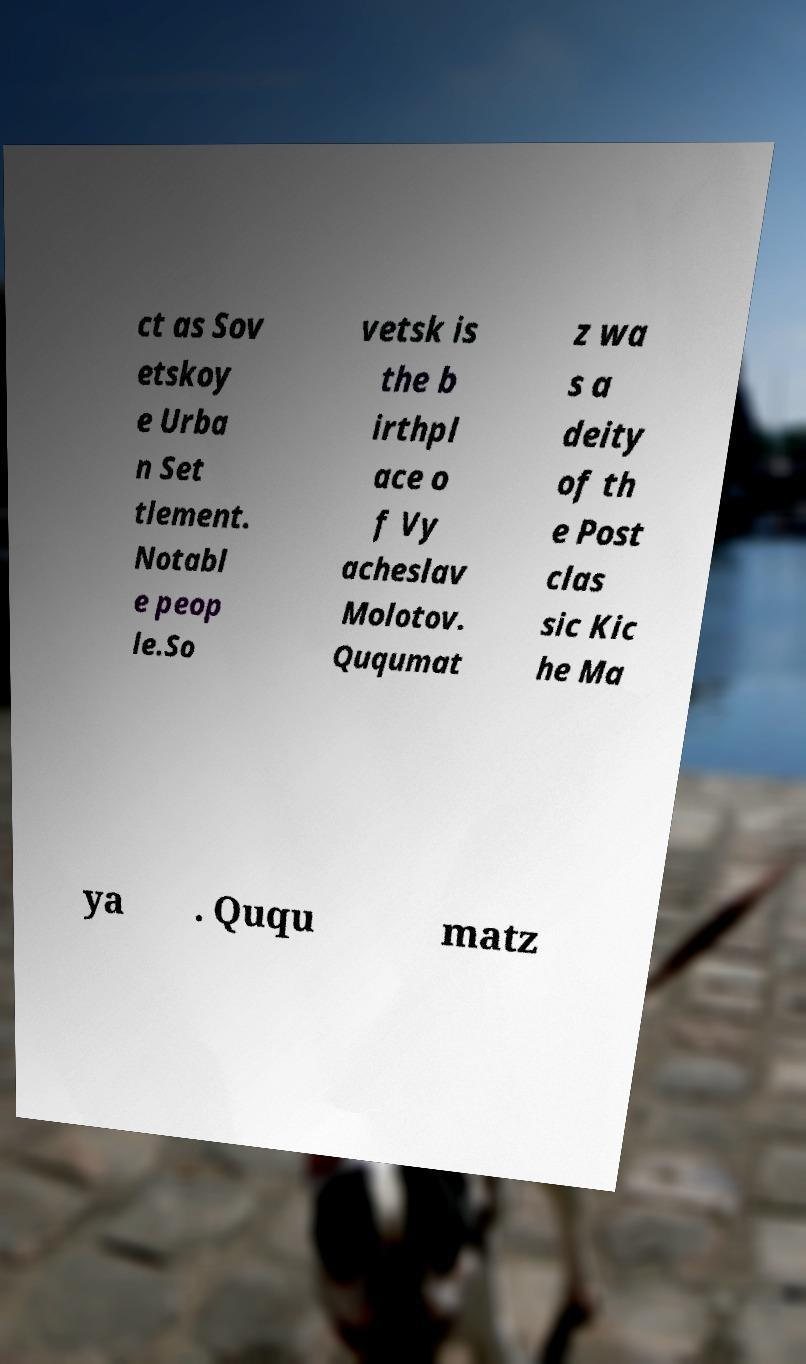Can you accurately transcribe the text from the provided image for me? ct as Sov etskoy e Urba n Set tlement. Notabl e peop le.So vetsk is the b irthpl ace o f Vy acheslav Molotov. Ququmat z wa s a deity of th e Post clas sic Kic he Ma ya . Ququ matz 